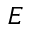Convert formula to latex. <formula><loc_0><loc_0><loc_500><loc_500>E</formula> 